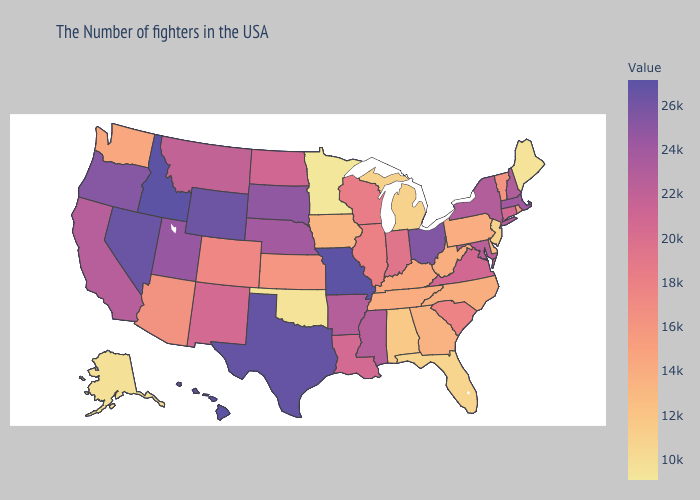Does Arizona have the lowest value in the West?
Be succinct. No. Among the states that border Colorado , does Oklahoma have the highest value?
Short answer required. No. Does the map have missing data?
Quick response, please. No. Does Maine have a higher value than Connecticut?
Be succinct. No. Among the states that border Montana , does South Dakota have the highest value?
Keep it brief. No. Among the states that border Indiana , does Michigan have the lowest value?
Answer briefly. Yes. Among the states that border Rhode Island , which have the lowest value?
Short answer required. Connecticut. Is the legend a continuous bar?
Short answer required. Yes. Among the states that border Virginia , does Maryland have the highest value?
Short answer required. Yes. 